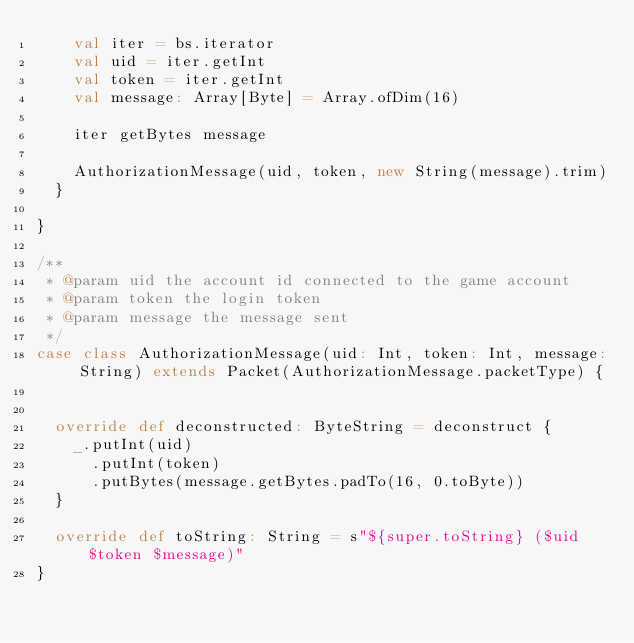<code> <loc_0><loc_0><loc_500><loc_500><_Scala_>    val iter = bs.iterator
    val uid = iter.getInt
    val token = iter.getInt
    val message: Array[Byte] = Array.ofDim(16)

    iter getBytes message

    AuthorizationMessage(uid, token, new String(message).trim)
  }

}

/**
 * @param uid the account id connected to the game account
 * @param token the login token
 * @param message the message sent
 */
case class AuthorizationMessage(uid: Int, token: Int, message: String) extends Packet(AuthorizationMessage.packetType) {


  override def deconstructed: ByteString = deconstruct {
    _.putInt(uid)
      .putInt(token)
      .putBytes(message.getBytes.padTo(16, 0.toByte))
  }

  override def toString: String = s"${super.toString} ($uid $token $message)"
}



















</code> 